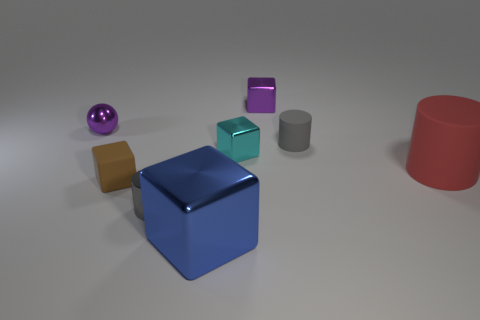Can you tell me the shapes of the objects that are not spherical? Apart from the spherical object, the image contains a cube, a couple of cuboids, and a cylindrical shape. 